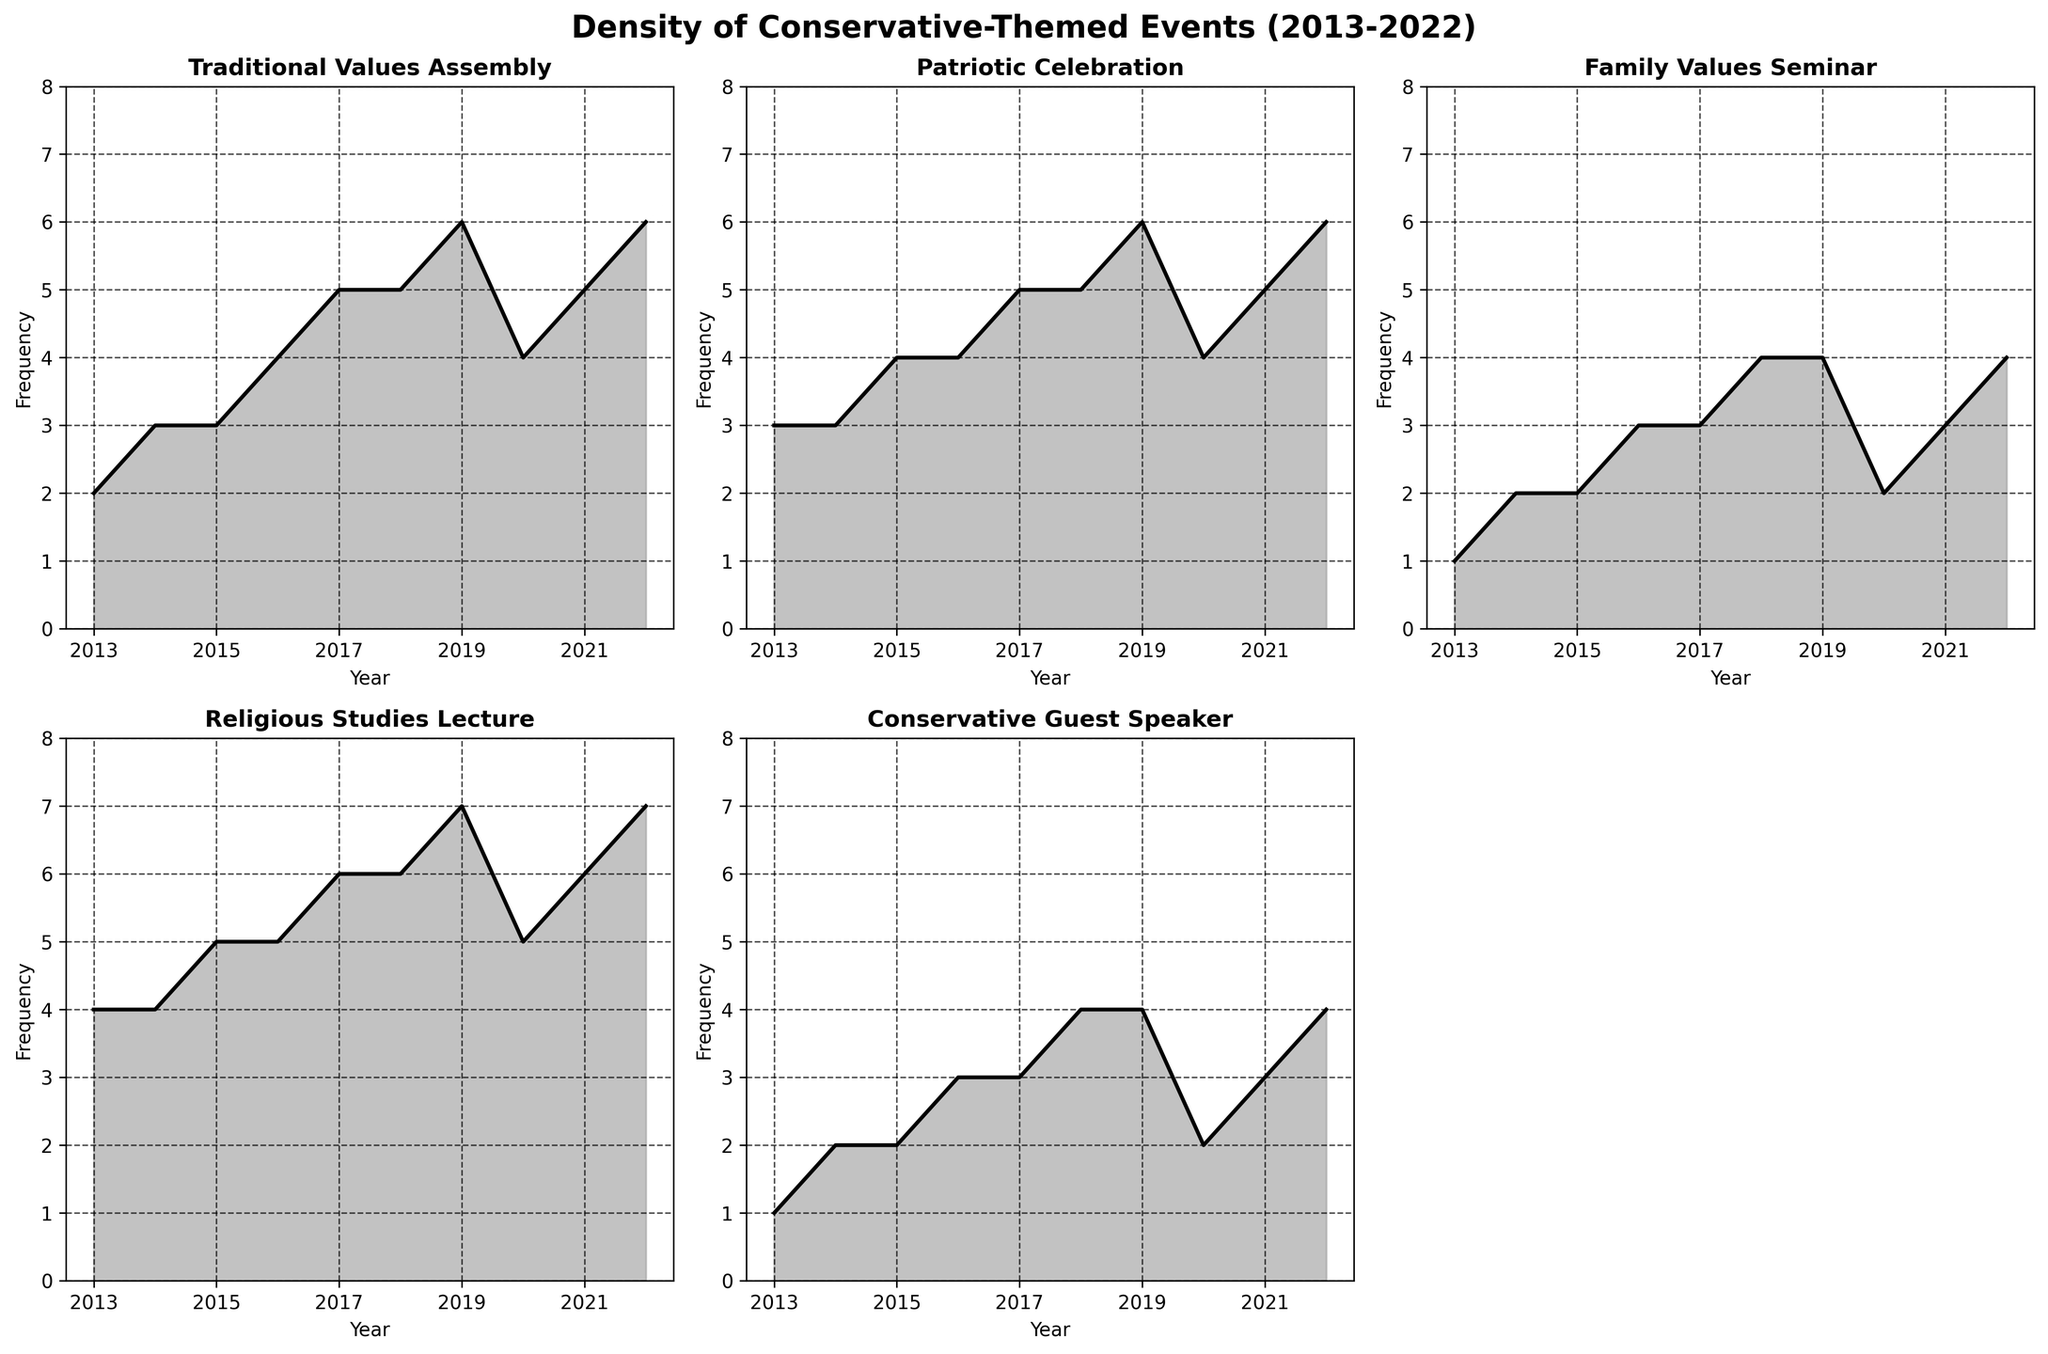What is the title of the figure? The title is displayed at the top center of the figure, which summarizes the content of the graph.
Answer: Density of Conservative-Themed Events (2013-2022) How many subplots are displayed in the figure? The figure contains multiple subplots, each representing a different type of event over time. By counting the separate visual plots, we see there are 5 subplots related to different events.
Answer: 5 Which event had the highest frequency in 2017? By looking at the 2017 data point across the subplots, we can compare the heights of the curves. The 'Religious Studies Lecture' subplot has the highest frequency in 2017.
Answer: Religious Studies Lecture Considering the years 2016 and 2018, which event showed a higher increase in frequency: 'Traditional Values Assembly' or 'Conservative Guest Speaker'? In 2016, 'Traditional Values Assembly' had a frequency of 4, and in 2018, it was 5 (a change of +1). 'Conservative Guest Speaker' had a frequency of 3 in 2016 and 4 in 2018 (+1). Both events showed an equal increase.
Answer: Both showed an equal increase Which year had the lowest overall frequency for the 'Family Values Seminar'? By scanning the 'Family Values Seminar' subplot, the shortest peak occurs for the year 2013.
Answer: 2013 Between 2015 and 2019, which two successive years show the greatest increase in frequency for 'Patriotic Celebration'? From the 'Patriotic Celebration' subplot: 
- 2015: 4
- 2016: 4 (increase +0)
- 2017: 5 (increase +1)
- 2018: 5 (increase +0)
- 2019: 6 (increase +1)
The increases were greatest from 2016 to 2017 and from 2018 to 2019.
Answer: 2018 to 2019 What is the general trend of 'Religious Studies Lecture' frequency from 2013 to 2022? The plot line in the 'Religious Studies Lecture' subplot generally trends upward, indicating an increase in event frequency over the years.
Answer: Upward trend How many events are depicted in the subplot figure? The subplots denote different types of conservative-themed events held over the years. There are 5 distinct event types plotted.
Answer: 5 What was the frequency of 'Traditional Values Assembly' in 2020? By examining the 'Traditional Values Assembly' subplot for the year 2020, the frequency is found as 4.
Answer: 4 Compare the overall frequency trends of 'Traditional Values Assembly' and 'Religious Studies Lecture'. Which one shows a more consistent yearly increase? By looking at the subplots for these two events, 'Traditional Values Assembly' has minor fluctuations, while 'Religious Studies Lecture' consistently increases each year.
Answer: Religious Studies Lecture 